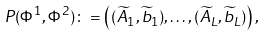Convert formula to latex. <formula><loc_0><loc_0><loc_500><loc_500>P ( \Phi ^ { 1 } , \Phi ^ { 2 } ) \colon = \left ( ( \widetilde { A } _ { 1 } , \widetilde { b } _ { 1 } ) , \dots , ( \widetilde { A } _ { L } , \widetilde { b } _ { L } ) \right ) ,</formula> 